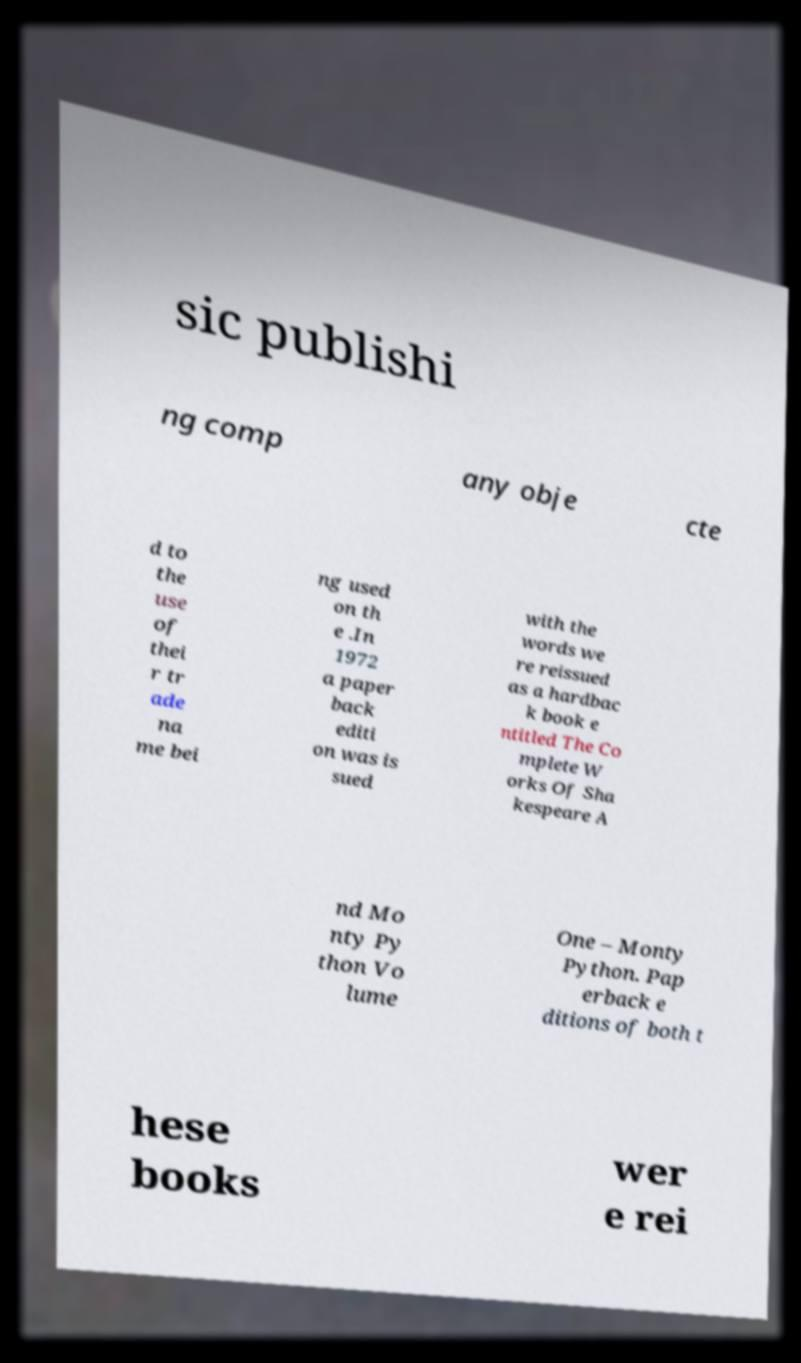There's text embedded in this image that I need extracted. Can you transcribe it verbatim? sic publishi ng comp any obje cte d to the use of thei r tr ade na me bei ng used on th e .In 1972 a paper back editi on was is sued with the words we re reissued as a hardbac k book e ntitled The Co mplete W orks Of Sha kespeare A nd Mo nty Py thon Vo lume One – Monty Python. Pap erback e ditions of both t hese books wer e rei 